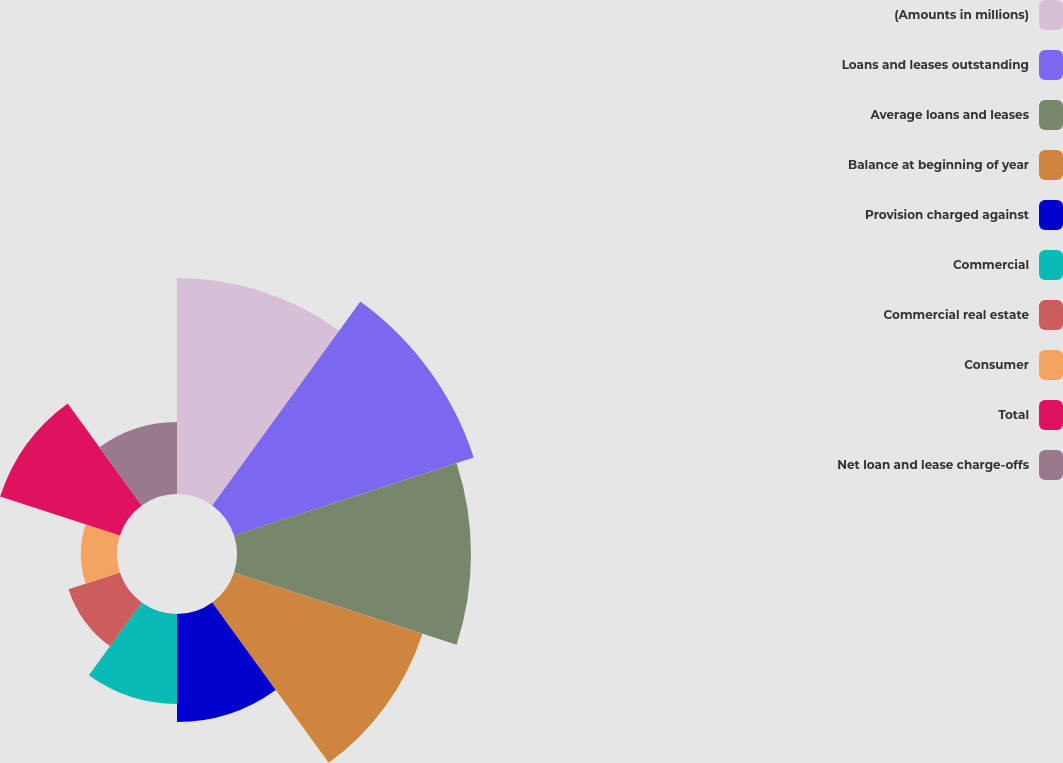Convert chart to OTSL. <chart><loc_0><loc_0><loc_500><loc_500><pie_chart><fcel>(Amounts in millions)<fcel>Loans and leases outstanding<fcel>Average loans and leases<fcel>Balance at beginning of year<fcel>Provision charged against<fcel>Commercial<fcel>Commercial real estate<fcel>Consumer<fcel>Total<fcel>Net loan and lease charge-offs<nl><fcel>15.58%<fcel>18.18%<fcel>16.88%<fcel>14.29%<fcel>7.79%<fcel>6.49%<fcel>3.9%<fcel>2.6%<fcel>9.09%<fcel>5.19%<nl></chart> 